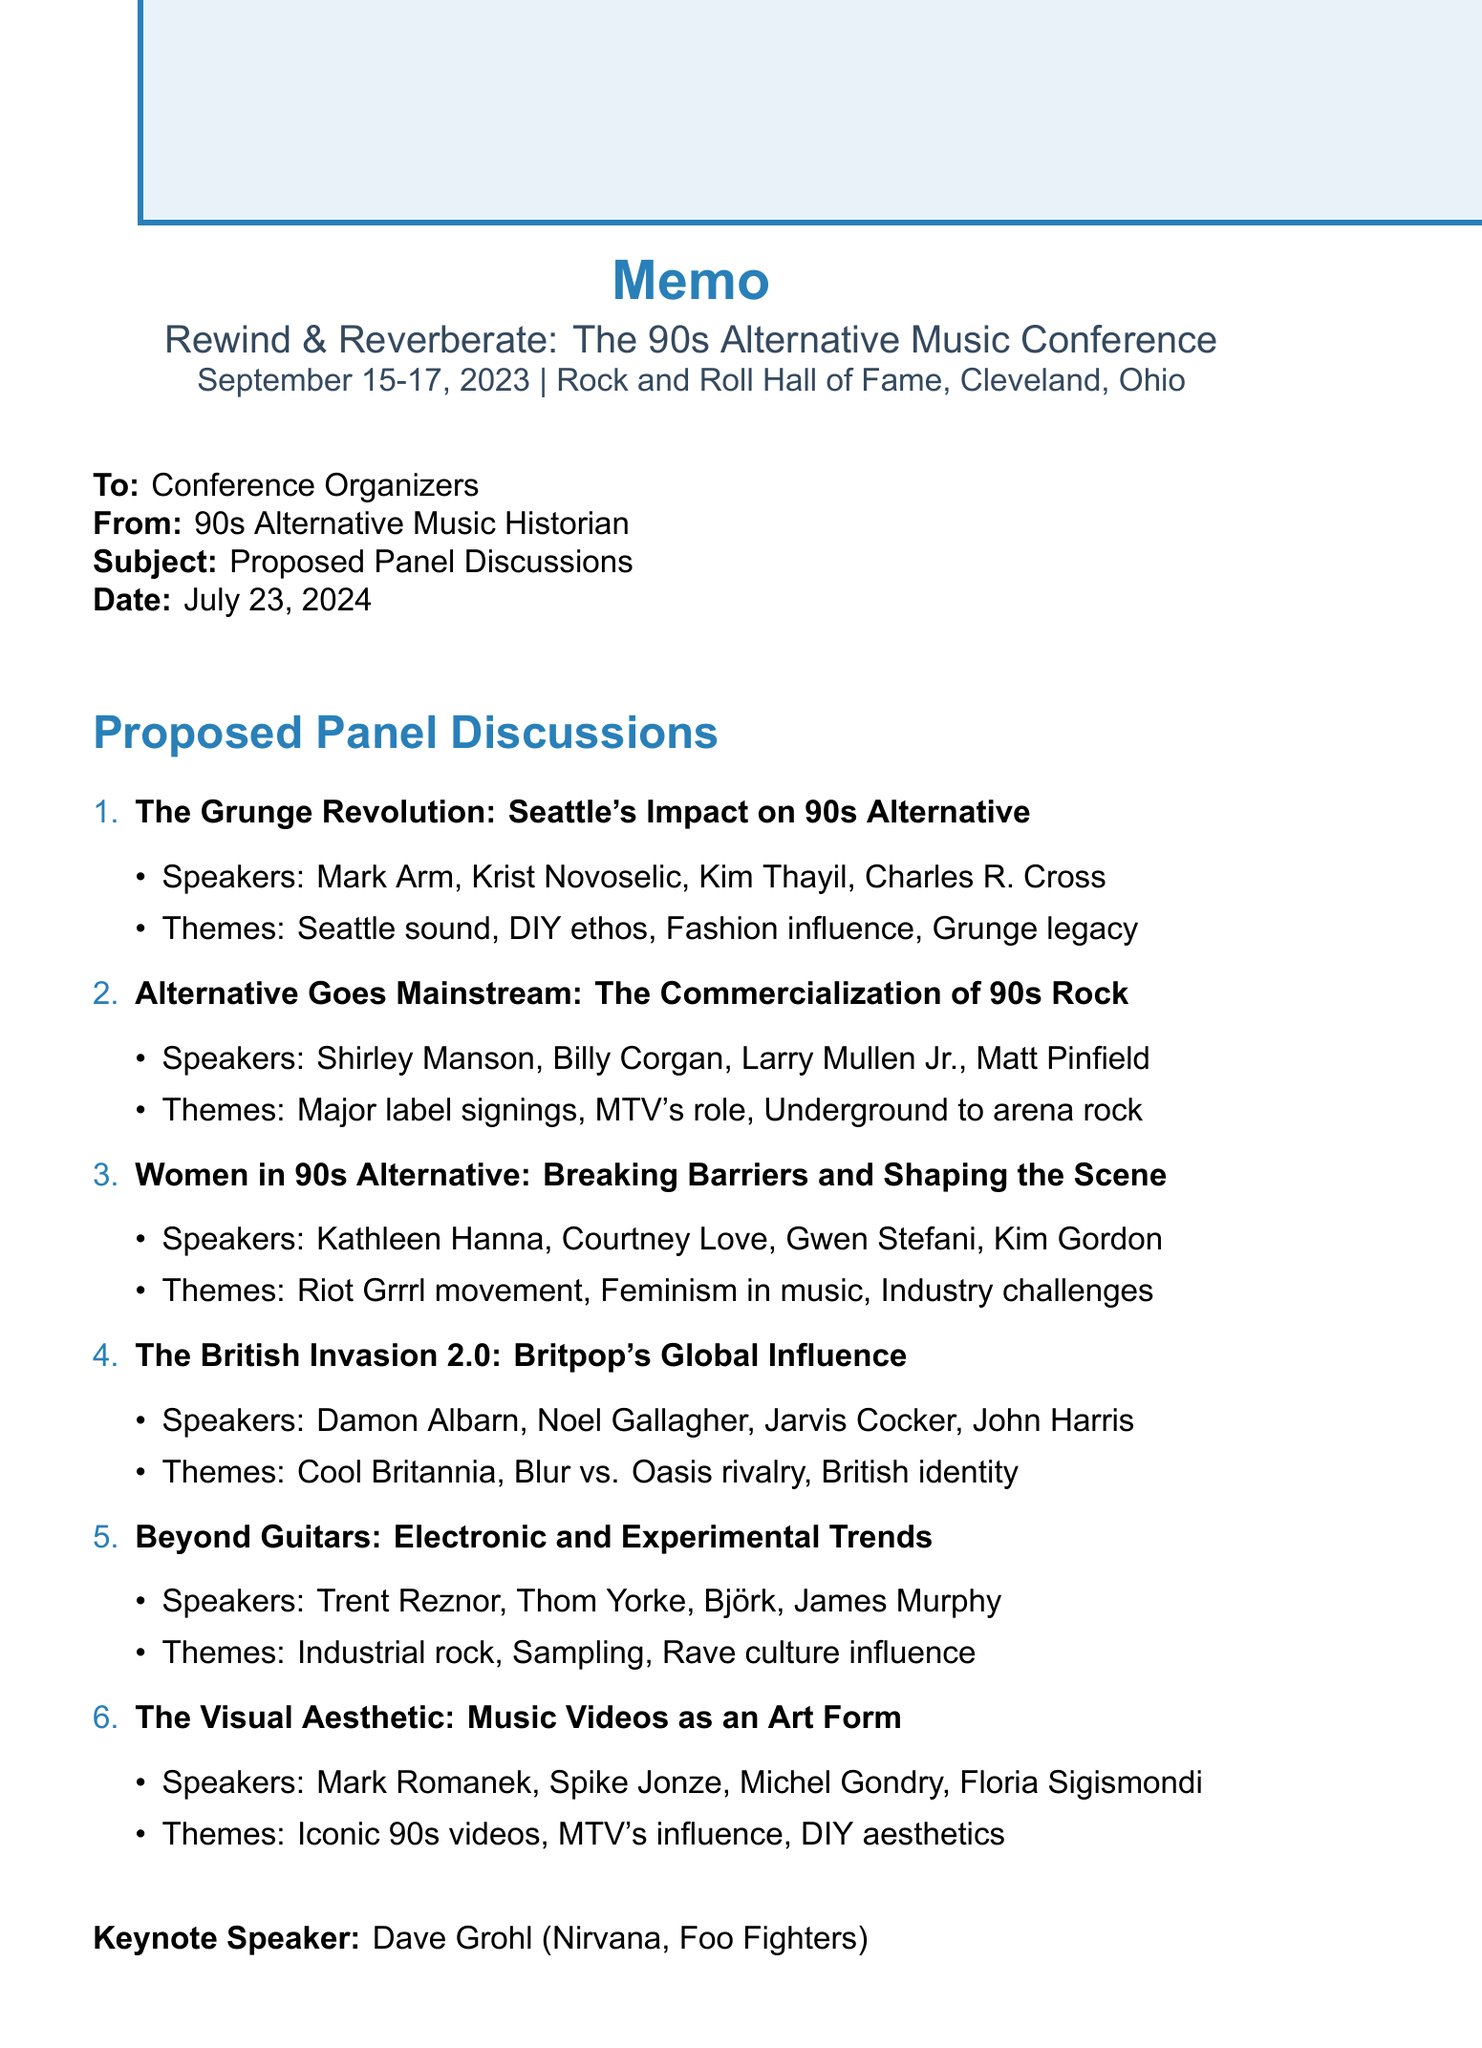What is the name of the conference? The document specifies the name of the conference, which is "Rewind & Reverberate: The 90s Alternative Music Conference."
Answer: Rewind & Reverberate: The 90s Alternative Music Conference When is the conference taking place? The document states the conference dates as September 15-17, 2023.
Answer: September 15-17, 2023 Who is the keynote speaker? The document identifies the keynote speaker as Dave Grohl.
Answer: Dave Grohl Which panel focuses on women in the music scene? The document lists the panel titled "Women in 90s Alternative: Breaking Barriers and Shaping the Scene" specifically about women in the music industry.
Answer: Women in 90s Alternative: Breaking Barriers and Shaping the Scene Who are the potential speakers for the Britpop panel? The document provides a list of potential speakers for the Britpop panel, which includes Damon Albarn, Noel Gallagher, Jarvis Cocker, and John Harris.
Answer: Damon Albarn, Noel Gallagher, Jarvis Cocker, John Harris Which theme discusses the role of MTV? The document mentions a key theme about MTV's influence in the panel titled "Alternative Goes Mainstream: The Commercialization of 90s Rock."
Answer: MTV's role What is a key theme of the grunge panel? The document highlights the "Legacy of grunge in modern rock" as one of the key themes for the grunge-related panel.
Answer: Legacy of grunge in modern rock What venue is hosting the conference? The document specifies that the conference will be held at the Rock and Roll Hall of Fame.
Answer: Rock and Roll Hall of Fame Which panel discusses electronic music trends? The document indicates the panel titled "Beyond Guitars: Electronic and Experimental Trends in 90s Alternative" focuses on electronic music trends.
Answer: Beyond Guitars: Electronic and Experimental Trends in 90s Alternative 